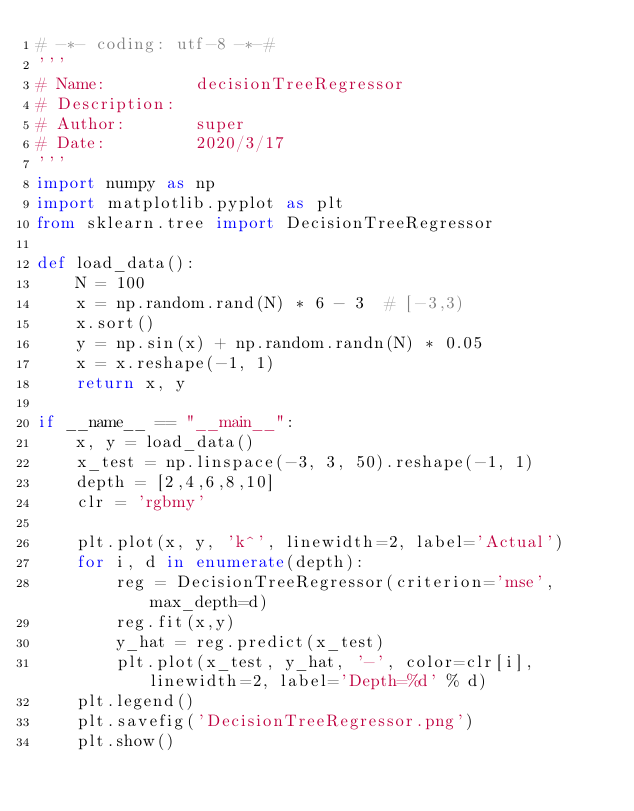Convert code to text. <code><loc_0><loc_0><loc_500><loc_500><_Python_># -*- coding: utf-8 -*-#
'''
# Name:         decisionTreeRegressor
# Description:  
# Author:       super
# Date:         2020/3/17
'''
import numpy as np
import matplotlib.pyplot as plt
from sklearn.tree import DecisionTreeRegressor

def load_data():
    N = 100
    x = np.random.rand(N) * 6 - 3  # [-3,3)
    x.sort()
    y = np.sin(x) + np.random.randn(N) * 0.05
    x = x.reshape(-1, 1)
    return x, y

if __name__ == "__main__":
    x, y = load_data()
    x_test = np.linspace(-3, 3, 50).reshape(-1, 1)
    depth = [2,4,6,8,10]
    clr = 'rgbmy'

    plt.plot(x, y, 'k^', linewidth=2, label='Actual')
    for i, d in enumerate(depth):
        reg = DecisionTreeRegressor(criterion='mse', max_depth=d)
        reg.fit(x,y)
        y_hat = reg.predict(x_test)
        plt.plot(x_test, y_hat, '-', color=clr[i], linewidth=2, label='Depth=%d' % d)
    plt.legend()
    plt.savefig('DecisionTreeRegressor.png')
    plt.show()</code> 